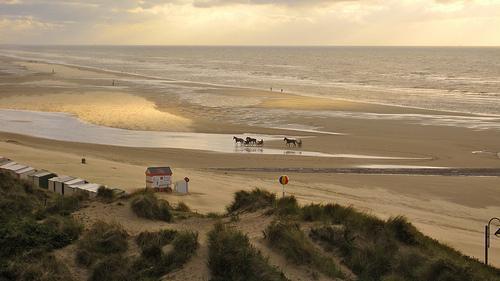How many balloons can be seen in this picture?
Give a very brief answer. 1. How many people are pictured here?
Give a very brief answer. 0. 